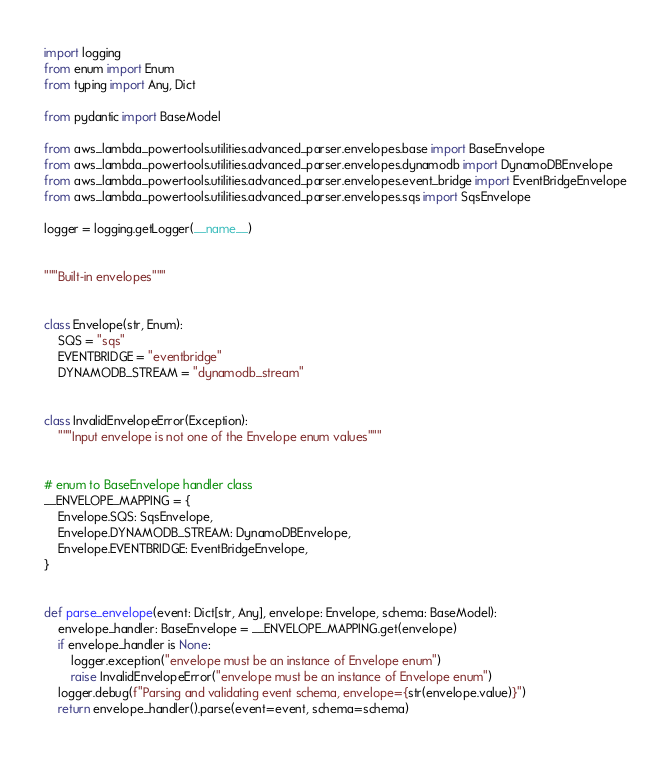Convert code to text. <code><loc_0><loc_0><loc_500><loc_500><_Python_>import logging
from enum import Enum
from typing import Any, Dict

from pydantic import BaseModel

from aws_lambda_powertools.utilities.advanced_parser.envelopes.base import BaseEnvelope
from aws_lambda_powertools.utilities.advanced_parser.envelopes.dynamodb import DynamoDBEnvelope
from aws_lambda_powertools.utilities.advanced_parser.envelopes.event_bridge import EventBridgeEnvelope
from aws_lambda_powertools.utilities.advanced_parser.envelopes.sqs import SqsEnvelope

logger = logging.getLogger(__name__)


"""Built-in envelopes"""


class Envelope(str, Enum):
    SQS = "sqs"
    EVENTBRIDGE = "eventbridge"
    DYNAMODB_STREAM = "dynamodb_stream"


class InvalidEnvelopeError(Exception):
    """Input envelope is not one of the Envelope enum values"""


# enum to BaseEnvelope handler class
__ENVELOPE_MAPPING = {
    Envelope.SQS: SqsEnvelope,
    Envelope.DYNAMODB_STREAM: DynamoDBEnvelope,
    Envelope.EVENTBRIDGE: EventBridgeEnvelope,
}


def parse_envelope(event: Dict[str, Any], envelope: Envelope, schema: BaseModel):
    envelope_handler: BaseEnvelope = __ENVELOPE_MAPPING.get(envelope)
    if envelope_handler is None:
        logger.exception("envelope must be an instance of Envelope enum")
        raise InvalidEnvelopeError("envelope must be an instance of Envelope enum")
    logger.debug(f"Parsing and validating event schema, envelope={str(envelope.value)}")
    return envelope_handler().parse(event=event, schema=schema)
</code> 